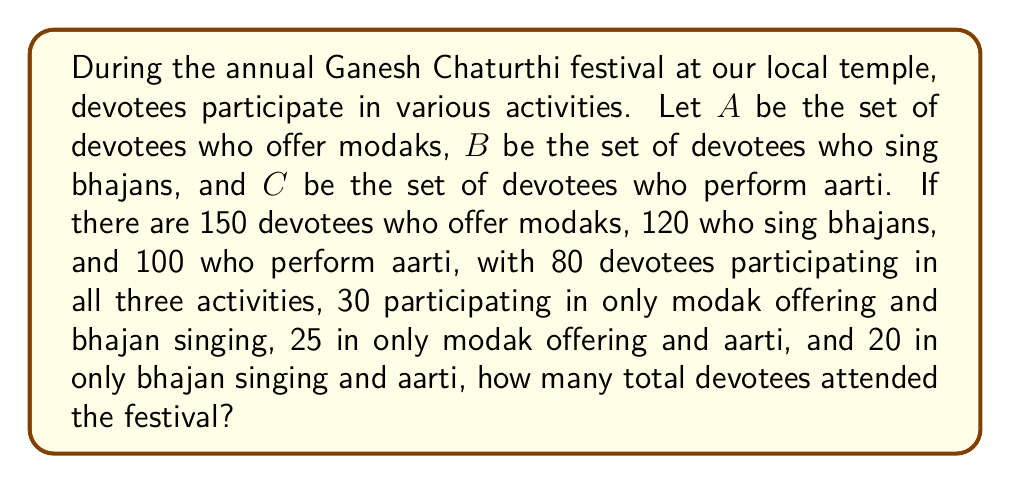Help me with this question. To solve this problem, we'll use the principle of inclusion-exclusion for three sets. Let's break it down step by step:

1) First, let's define our sets:
   A: devotees who offer modaks
   B: devotees who sing bhajans
   C: devotees who perform aarti

2) We're given:
   $|A| = 150$, $|B| = 120$, $|C| = 100$
   $|A \cap B \cap C| = 80$
   $|A \cap B| - |A \cap B \cap C| = 30$
   $|A \cap C| - |A \cap B \cap C| = 25$
   $|B \cap C| - |A \cap B \cap C| = 20$

3) We need to find $|A \cup B \cup C|$. The formula for this is:

   $$|A \cup B \cup C| = |A| + |B| + |C| - |A \cap B| - |A \cap C| - |B \cap C| + |A \cap B \cap C|$$

4) We know $|A|$, $|B|$, $|C|$, and $|A \cap B \cap C|$. We need to find $|A \cap B|$, $|A \cap C|$, and $|B \cap C|$:

   $|A \cap B| = (|A \cap B| - |A \cap B \cap C|) + |A \cap B \cap C| = 30 + 80 = 110$
   $|A \cap C| = (|A \cap C| - |A \cap B \cap C|) + |A \cap B \cap C| = 25 + 80 = 105$
   $|B \cap C| = (|B \cap C| - |A \cap B \cap C|) + |A \cap B \cap C| = 20 + 80 = 100$

5) Now we can substitute these values into our formula:

   $$|A \cup B \cup C| = 150 + 120 + 100 - 110 - 105 - 100 + 80 = 135$$

Therefore, the total number of devotees who attended the festival is 135.
Answer: 135 devotees 